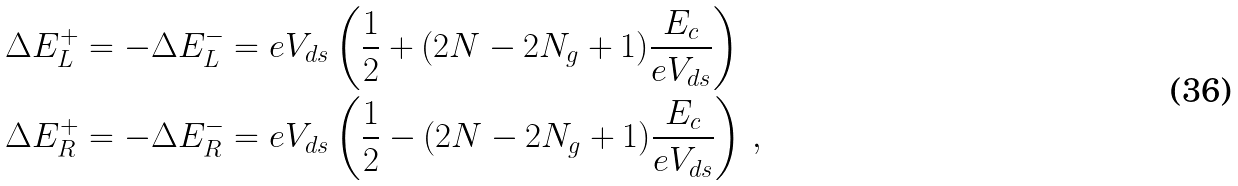Convert formula to latex. <formula><loc_0><loc_0><loc_500><loc_500>\Delta E ^ { + } _ { L } & = - \Delta E ^ { - } _ { L } = e V _ { d s } \left ( \frac { 1 } { 2 } + ( 2 N - 2 N _ { g } + 1 ) \frac { E _ { c } } { e V _ { d s } } \right ) \\ \Delta E ^ { + } _ { R } & = - \Delta E ^ { - } _ { R } = e V _ { d s } \left ( \frac { 1 } { 2 } - ( 2 N - 2 N _ { g } + 1 ) \frac { E _ { c } } { e V _ { d s } } \right ) \, ,</formula> 